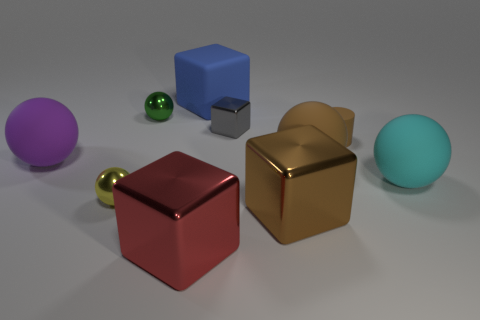What number of other things are there of the same shape as the big blue rubber thing?
Provide a short and direct response. 3. Are there any big brown shiny cubes left of the big blue thing?
Offer a very short reply. No. The tiny cube is what color?
Offer a very short reply. Gray. There is a small cylinder; does it have the same color as the thing left of the yellow metal sphere?
Give a very brief answer. No. Are there any other blocks of the same size as the gray metallic block?
Keep it short and to the point. No. The cube that is the same color as the small cylinder is what size?
Provide a short and direct response. Large. There is a cube to the right of the small metal cube; what material is it?
Your response must be concise. Metal. Are there the same number of big cubes in front of the tiny rubber object and green shiny objects that are in front of the green ball?
Your answer should be very brief. No. There is a matte ball to the left of the large red shiny cube; is it the same size as the matte object that is behind the small green sphere?
Ensure brevity in your answer.  Yes. What number of things have the same color as the tiny shiny cube?
Your response must be concise. 0. 